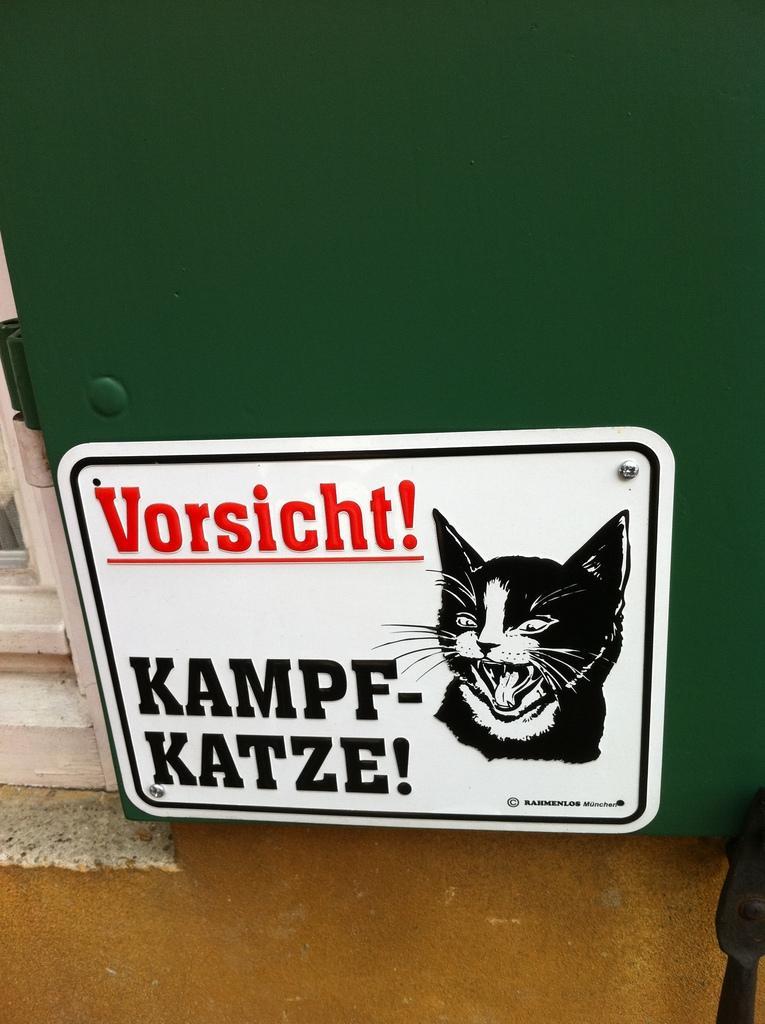Describe this image in one or two sentences. In this picture we can see cats cartoon. Here we can see white color steel plate. On the left there is a door. On the bottom there is a floor. 